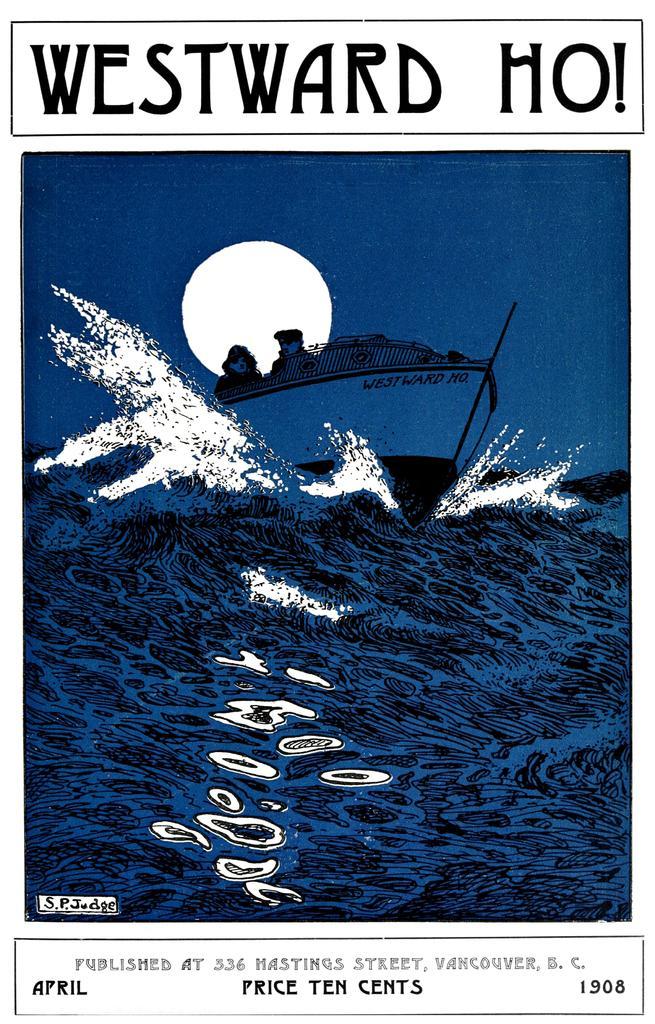Could you give a brief overview of what you see in this image? In the image we can see a poster. In the poster there is water and boat. 